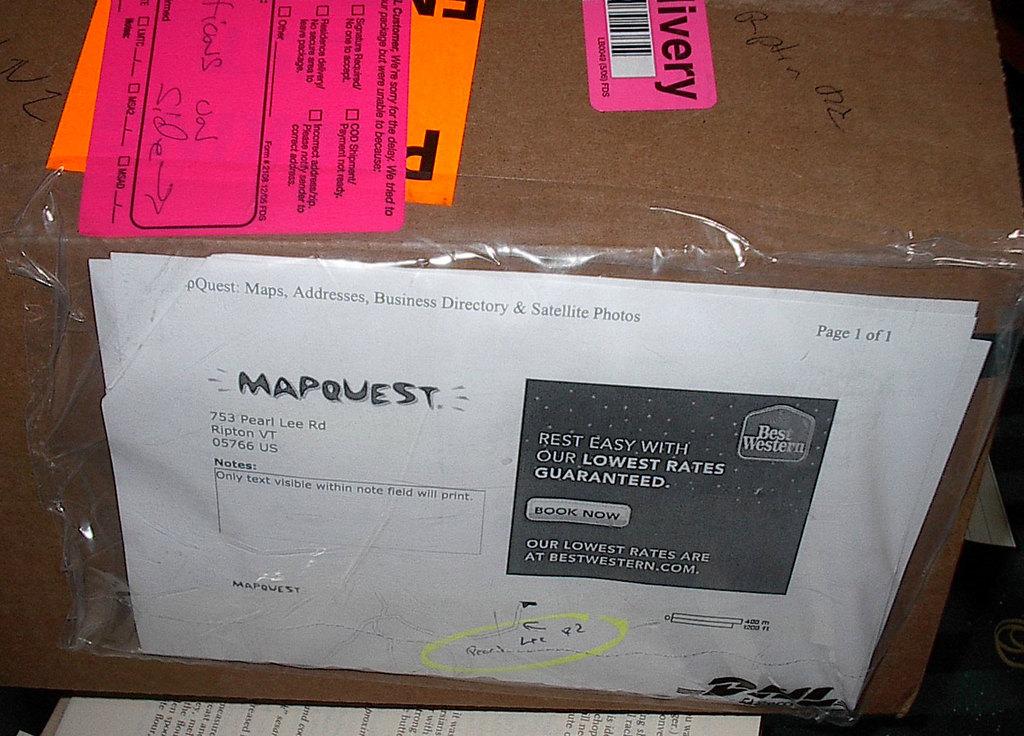What hotel is advertised on the letter?
Your answer should be compact. Best western. What is the street address on the box?
Provide a short and direct response. 753 pearl lee rd. 